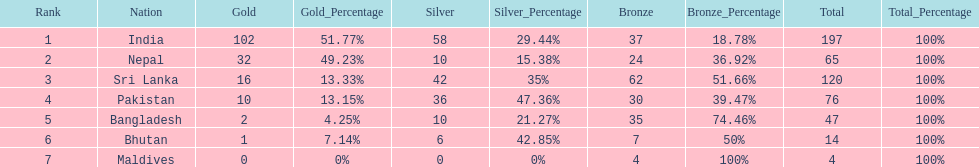What is the collective sum of gold medals won by the seven nations? 163. 